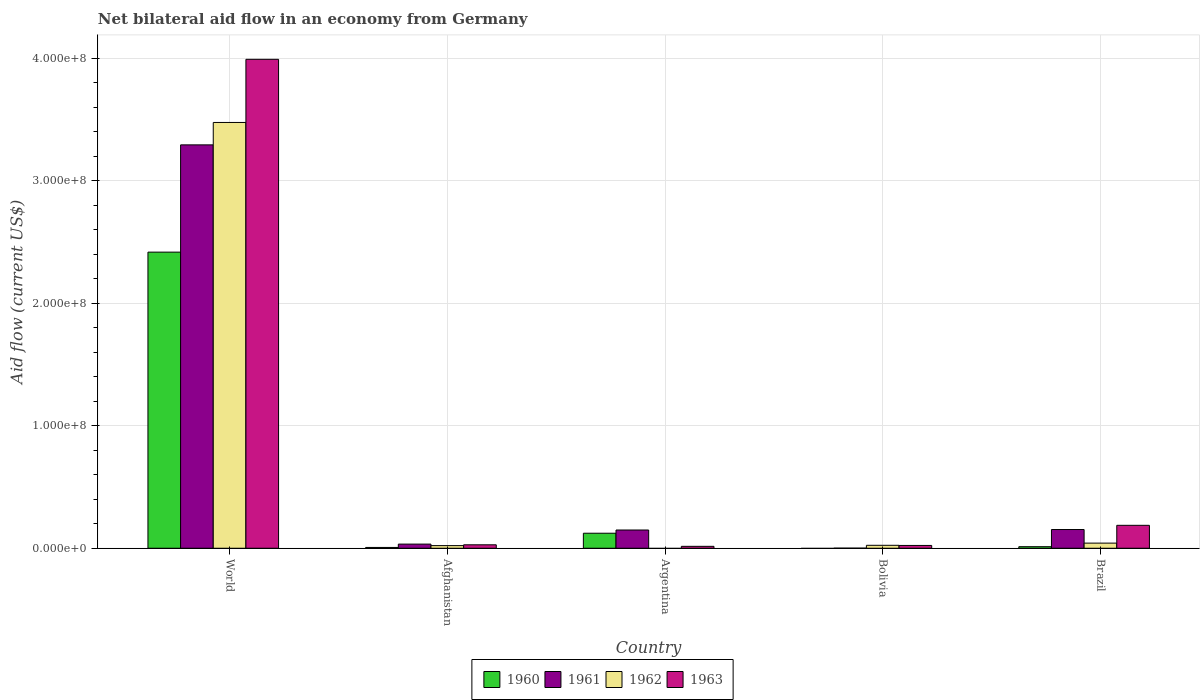How many different coloured bars are there?
Keep it short and to the point. 4. Are the number of bars per tick equal to the number of legend labels?
Make the answer very short. No. How many bars are there on the 5th tick from the left?
Your answer should be very brief. 4. What is the label of the 3rd group of bars from the left?
Offer a terse response. Argentina. What is the net bilateral aid flow in 1962 in Afghanistan?
Make the answer very short. 2.15e+06. Across all countries, what is the maximum net bilateral aid flow in 1960?
Make the answer very short. 2.42e+08. Across all countries, what is the minimum net bilateral aid flow in 1960?
Your answer should be very brief. 0. What is the total net bilateral aid flow in 1963 in the graph?
Ensure brevity in your answer.  4.24e+08. What is the difference between the net bilateral aid flow in 1962 in Afghanistan and that in Bolivia?
Your answer should be compact. -2.50e+05. What is the difference between the net bilateral aid flow in 1963 in Bolivia and the net bilateral aid flow in 1960 in Afghanistan?
Make the answer very short. 1.63e+06. What is the average net bilateral aid flow in 1961 per country?
Your answer should be compact. 7.25e+07. What is the difference between the net bilateral aid flow of/in 1961 and net bilateral aid flow of/in 1960 in World?
Ensure brevity in your answer.  8.75e+07. What is the ratio of the net bilateral aid flow in 1962 in Afghanistan to that in World?
Your response must be concise. 0.01. Is the net bilateral aid flow in 1963 in Afghanistan less than that in Bolivia?
Offer a terse response. No. What is the difference between the highest and the second highest net bilateral aid flow in 1962?
Make the answer very short. 3.45e+08. What is the difference between the highest and the lowest net bilateral aid flow in 1960?
Provide a succinct answer. 2.42e+08. Is it the case that in every country, the sum of the net bilateral aid flow in 1961 and net bilateral aid flow in 1963 is greater than the sum of net bilateral aid flow in 1960 and net bilateral aid flow in 1962?
Provide a short and direct response. No. Is it the case that in every country, the sum of the net bilateral aid flow in 1963 and net bilateral aid flow in 1961 is greater than the net bilateral aid flow in 1962?
Ensure brevity in your answer.  No. How many bars are there?
Make the answer very short. 18. Does the graph contain any zero values?
Provide a short and direct response. Yes. Where does the legend appear in the graph?
Your answer should be compact. Bottom center. How are the legend labels stacked?
Make the answer very short. Horizontal. What is the title of the graph?
Offer a terse response. Net bilateral aid flow in an economy from Germany. What is the label or title of the Y-axis?
Give a very brief answer. Aid flow (current US$). What is the Aid flow (current US$) of 1960 in World?
Provide a short and direct response. 2.42e+08. What is the Aid flow (current US$) of 1961 in World?
Ensure brevity in your answer.  3.29e+08. What is the Aid flow (current US$) in 1962 in World?
Your answer should be compact. 3.47e+08. What is the Aid flow (current US$) in 1963 in World?
Offer a very short reply. 3.99e+08. What is the Aid flow (current US$) in 1960 in Afghanistan?
Your answer should be very brief. 6.50e+05. What is the Aid flow (current US$) of 1961 in Afghanistan?
Your answer should be very brief. 3.38e+06. What is the Aid flow (current US$) of 1962 in Afghanistan?
Give a very brief answer. 2.15e+06. What is the Aid flow (current US$) of 1963 in Afghanistan?
Your answer should be compact. 2.81e+06. What is the Aid flow (current US$) of 1960 in Argentina?
Give a very brief answer. 1.23e+07. What is the Aid flow (current US$) of 1961 in Argentina?
Give a very brief answer. 1.49e+07. What is the Aid flow (current US$) in 1963 in Argentina?
Provide a succinct answer. 1.56e+06. What is the Aid flow (current US$) in 1961 in Bolivia?
Provide a short and direct response. 7.00e+04. What is the Aid flow (current US$) in 1962 in Bolivia?
Give a very brief answer. 2.40e+06. What is the Aid flow (current US$) in 1963 in Bolivia?
Provide a succinct answer. 2.28e+06. What is the Aid flow (current US$) in 1960 in Brazil?
Keep it short and to the point. 1.26e+06. What is the Aid flow (current US$) of 1961 in Brazil?
Provide a short and direct response. 1.53e+07. What is the Aid flow (current US$) in 1962 in Brazil?
Provide a succinct answer. 4.19e+06. What is the Aid flow (current US$) in 1963 in Brazil?
Keep it short and to the point. 1.87e+07. Across all countries, what is the maximum Aid flow (current US$) in 1960?
Your answer should be compact. 2.42e+08. Across all countries, what is the maximum Aid flow (current US$) of 1961?
Make the answer very short. 3.29e+08. Across all countries, what is the maximum Aid flow (current US$) in 1962?
Keep it short and to the point. 3.47e+08. Across all countries, what is the maximum Aid flow (current US$) in 1963?
Your answer should be very brief. 3.99e+08. Across all countries, what is the minimum Aid flow (current US$) of 1960?
Ensure brevity in your answer.  0. Across all countries, what is the minimum Aid flow (current US$) in 1962?
Ensure brevity in your answer.  0. Across all countries, what is the minimum Aid flow (current US$) of 1963?
Keep it short and to the point. 1.56e+06. What is the total Aid flow (current US$) in 1960 in the graph?
Give a very brief answer. 2.56e+08. What is the total Aid flow (current US$) in 1961 in the graph?
Keep it short and to the point. 3.63e+08. What is the total Aid flow (current US$) in 1962 in the graph?
Your response must be concise. 3.56e+08. What is the total Aid flow (current US$) in 1963 in the graph?
Offer a terse response. 4.24e+08. What is the difference between the Aid flow (current US$) in 1960 in World and that in Afghanistan?
Provide a succinct answer. 2.41e+08. What is the difference between the Aid flow (current US$) of 1961 in World and that in Afghanistan?
Make the answer very short. 3.26e+08. What is the difference between the Aid flow (current US$) of 1962 in World and that in Afghanistan?
Your answer should be very brief. 3.45e+08. What is the difference between the Aid flow (current US$) of 1963 in World and that in Afghanistan?
Provide a succinct answer. 3.96e+08. What is the difference between the Aid flow (current US$) of 1960 in World and that in Argentina?
Your answer should be compact. 2.29e+08. What is the difference between the Aid flow (current US$) of 1961 in World and that in Argentina?
Keep it short and to the point. 3.14e+08. What is the difference between the Aid flow (current US$) in 1963 in World and that in Argentina?
Keep it short and to the point. 3.97e+08. What is the difference between the Aid flow (current US$) of 1961 in World and that in Bolivia?
Offer a terse response. 3.29e+08. What is the difference between the Aid flow (current US$) in 1962 in World and that in Bolivia?
Your answer should be compact. 3.45e+08. What is the difference between the Aid flow (current US$) of 1963 in World and that in Bolivia?
Ensure brevity in your answer.  3.97e+08. What is the difference between the Aid flow (current US$) of 1960 in World and that in Brazil?
Ensure brevity in your answer.  2.40e+08. What is the difference between the Aid flow (current US$) in 1961 in World and that in Brazil?
Make the answer very short. 3.14e+08. What is the difference between the Aid flow (current US$) of 1962 in World and that in Brazil?
Offer a very short reply. 3.43e+08. What is the difference between the Aid flow (current US$) in 1963 in World and that in Brazil?
Ensure brevity in your answer.  3.80e+08. What is the difference between the Aid flow (current US$) of 1960 in Afghanistan and that in Argentina?
Offer a very short reply. -1.16e+07. What is the difference between the Aid flow (current US$) in 1961 in Afghanistan and that in Argentina?
Keep it short and to the point. -1.15e+07. What is the difference between the Aid flow (current US$) of 1963 in Afghanistan and that in Argentina?
Keep it short and to the point. 1.25e+06. What is the difference between the Aid flow (current US$) in 1961 in Afghanistan and that in Bolivia?
Provide a succinct answer. 3.31e+06. What is the difference between the Aid flow (current US$) in 1962 in Afghanistan and that in Bolivia?
Provide a short and direct response. -2.50e+05. What is the difference between the Aid flow (current US$) in 1963 in Afghanistan and that in Bolivia?
Your answer should be very brief. 5.30e+05. What is the difference between the Aid flow (current US$) in 1960 in Afghanistan and that in Brazil?
Your answer should be very brief. -6.10e+05. What is the difference between the Aid flow (current US$) of 1961 in Afghanistan and that in Brazil?
Your answer should be compact. -1.19e+07. What is the difference between the Aid flow (current US$) of 1962 in Afghanistan and that in Brazil?
Give a very brief answer. -2.04e+06. What is the difference between the Aid flow (current US$) in 1963 in Afghanistan and that in Brazil?
Offer a very short reply. -1.59e+07. What is the difference between the Aid flow (current US$) in 1961 in Argentina and that in Bolivia?
Your response must be concise. 1.48e+07. What is the difference between the Aid flow (current US$) of 1963 in Argentina and that in Bolivia?
Ensure brevity in your answer.  -7.20e+05. What is the difference between the Aid flow (current US$) in 1960 in Argentina and that in Brazil?
Offer a very short reply. 1.10e+07. What is the difference between the Aid flow (current US$) in 1961 in Argentina and that in Brazil?
Ensure brevity in your answer.  -3.90e+05. What is the difference between the Aid flow (current US$) of 1963 in Argentina and that in Brazil?
Provide a short and direct response. -1.71e+07. What is the difference between the Aid flow (current US$) of 1961 in Bolivia and that in Brazil?
Keep it short and to the point. -1.52e+07. What is the difference between the Aid flow (current US$) in 1962 in Bolivia and that in Brazil?
Your answer should be very brief. -1.79e+06. What is the difference between the Aid flow (current US$) of 1963 in Bolivia and that in Brazil?
Your response must be concise. -1.64e+07. What is the difference between the Aid flow (current US$) in 1960 in World and the Aid flow (current US$) in 1961 in Afghanistan?
Make the answer very short. 2.38e+08. What is the difference between the Aid flow (current US$) of 1960 in World and the Aid flow (current US$) of 1962 in Afghanistan?
Ensure brevity in your answer.  2.39e+08. What is the difference between the Aid flow (current US$) in 1960 in World and the Aid flow (current US$) in 1963 in Afghanistan?
Your answer should be very brief. 2.39e+08. What is the difference between the Aid flow (current US$) of 1961 in World and the Aid flow (current US$) of 1962 in Afghanistan?
Make the answer very short. 3.27e+08. What is the difference between the Aid flow (current US$) of 1961 in World and the Aid flow (current US$) of 1963 in Afghanistan?
Provide a short and direct response. 3.26e+08. What is the difference between the Aid flow (current US$) in 1962 in World and the Aid flow (current US$) in 1963 in Afghanistan?
Ensure brevity in your answer.  3.45e+08. What is the difference between the Aid flow (current US$) in 1960 in World and the Aid flow (current US$) in 1961 in Argentina?
Keep it short and to the point. 2.27e+08. What is the difference between the Aid flow (current US$) in 1960 in World and the Aid flow (current US$) in 1963 in Argentina?
Make the answer very short. 2.40e+08. What is the difference between the Aid flow (current US$) in 1961 in World and the Aid flow (current US$) in 1963 in Argentina?
Ensure brevity in your answer.  3.28e+08. What is the difference between the Aid flow (current US$) of 1962 in World and the Aid flow (current US$) of 1963 in Argentina?
Offer a very short reply. 3.46e+08. What is the difference between the Aid flow (current US$) of 1960 in World and the Aid flow (current US$) of 1961 in Bolivia?
Keep it short and to the point. 2.42e+08. What is the difference between the Aid flow (current US$) of 1960 in World and the Aid flow (current US$) of 1962 in Bolivia?
Give a very brief answer. 2.39e+08. What is the difference between the Aid flow (current US$) of 1960 in World and the Aid flow (current US$) of 1963 in Bolivia?
Provide a short and direct response. 2.39e+08. What is the difference between the Aid flow (current US$) in 1961 in World and the Aid flow (current US$) in 1962 in Bolivia?
Give a very brief answer. 3.27e+08. What is the difference between the Aid flow (current US$) of 1961 in World and the Aid flow (current US$) of 1963 in Bolivia?
Your answer should be compact. 3.27e+08. What is the difference between the Aid flow (current US$) of 1962 in World and the Aid flow (current US$) of 1963 in Bolivia?
Give a very brief answer. 3.45e+08. What is the difference between the Aid flow (current US$) of 1960 in World and the Aid flow (current US$) of 1961 in Brazil?
Provide a succinct answer. 2.26e+08. What is the difference between the Aid flow (current US$) in 1960 in World and the Aid flow (current US$) in 1962 in Brazil?
Your answer should be compact. 2.37e+08. What is the difference between the Aid flow (current US$) in 1960 in World and the Aid flow (current US$) in 1963 in Brazil?
Ensure brevity in your answer.  2.23e+08. What is the difference between the Aid flow (current US$) in 1961 in World and the Aid flow (current US$) in 1962 in Brazil?
Offer a terse response. 3.25e+08. What is the difference between the Aid flow (current US$) in 1961 in World and the Aid flow (current US$) in 1963 in Brazil?
Provide a succinct answer. 3.10e+08. What is the difference between the Aid flow (current US$) of 1962 in World and the Aid flow (current US$) of 1963 in Brazil?
Provide a succinct answer. 3.29e+08. What is the difference between the Aid flow (current US$) in 1960 in Afghanistan and the Aid flow (current US$) in 1961 in Argentina?
Offer a very short reply. -1.42e+07. What is the difference between the Aid flow (current US$) of 1960 in Afghanistan and the Aid flow (current US$) of 1963 in Argentina?
Provide a short and direct response. -9.10e+05. What is the difference between the Aid flow (current US$) in 1961 in Afghanistan and the Aid flow (current US$) in 1963 in Argentina?
Make the answer very short. 1.82e+06. What is the difference between the Aid flow (current US$) in 1962 in Afghanistan and the Aid flow (current US$) in 1963 in Argentina?
Provide a short and direct response. 5.90e+05. What is the difference between the Aid flow (current US$) of 1960 in Afghanistan and the Aid flow (current US$) of 1961 in Bolivia?
Provide a succinct answer. 5.80e+05. What is the difference between the Aid flow (current US$) in 1960 in Afghanistan and the Aid flow (current US$) in 1962 in Bolivia?
Give a very brief answer. -1.75e+06. What is the difference between the Aid flow (current US$) in 1960 in Afghanistan and the Aid flow (current US$) in 1963 in Bolivia?
Keep it short and to the point. -1.63e+06. What is the difference between the Aid flow (current US$) of 1961 in Afghanistan and the Aid flow (current US$) of 1962 in Bolivia?
Your answer should be very brief. 9.80e+05. What is the difference between the Aid flow (current US$) of 1961 in Afghanistan and the Aid flow (current US$) of 1963 in Bolivia?
Provide a short and direct response. 1.10e+06. What is the difference between the Aid flow (current US$) of 1960 in Afghanistan and the Aid flow (current US$) of 1961 in Brazil?
Provide a succinct answer. -1.46e+07. What is the difference between the Aid flow (current US$) of 1960 in Afghanistan and the Aid flow (current US$) of 1962 in Brazil?
Provide a short and direct response. -3.54e+06. What is the difference between the Aid flow (current US$) of 1960 in Afghanistan and the Aid flow (current US$) of 1963 in Brazil?
Provide a short and direct response. -1.80e+07. What is the difference between the Aid flow (current US$) in 1961 in Afghanistan and the Aid flow (current US$) in 1962 in Brazil?
Ensure brevity in your answer.  -8.10e+05. What is the difference between the Aid flow (current US$) in 1961 in Afghanistan and the Aid flow (current US$) in 1963 in Brazil?
Offer a very short reply. -1.53e+07. What is the difference between the Aid flow (current US$) in 1962 in Afghanistan and the Aid flow (current US$) in 1963 in Brazil?
Provide a short and direct response. -1.66e+07. What is the difference between the Aid flow (current US$) in 1960 in Argentina and the Aid flow (current US$) in 1961 in Bolivia?
Provide a short and direct response. 1.22e+07. What is the difference between the Aid flow (current US$) of 1960 in Argentina and the Aid flow (current US$) of 1962 in Bolivia?
Ensure brevity in your answer.  9.86e+06. What is the difference between the Aid flow (current US$) of 1960 in Argentina and the Aid flow (current US$) of 1963 in Bolivia?
Keep it short and to the point. 9.98e+06. What is the difference between the Aid flow (current US$) in 1961 in Argentina and the Aid flow (current US$) in 1962 in Bolivia?
Provide a succinct answer. 1.25e+07. What is the difference between the Aid flow (current US$) of 1961 in Argentina and the Aid flow (current US$) of 1963 in Bolivia?
Ensure brevity in your answer.  1.26e+07. What is the difference between the Aid flow (current US$) of 1960 in Argentina and the Aid flow (current US$) of 1961 in Brazil?
Offer a terse response. -3.01e+06. What is the difference between the Aid flow (current US$) in 1960 in Argentina and the Aid flow (current US$) in 1962 in Brazil?
Your answer should be compact. 8.07e+06. What is the difference between the Aid flow (current US$) in 1960 in Argentina and the Aid flow (current US$) in 1963 in Brazil?
Offer a very short reply. -6.44e+06. What is the difference between the Aid flow (current US$) of 1961 in Argentina and the Aid flow (current US$) of 1962 in Brazil?
Give a very brief answer. 1.07e+07. What is the difference between the Aid flow (current US$) of 1961 in Argentina and the Aid flow (current US$) of 1963 in Brazil?
Ensure brevity in your answer.  -3.82e+06. What is the difference between the Aid flow (current US$) in 1961 in Bolivia and the Aid flow (current US$) in 1962 in Brazil?
Offer a terse response. -4.12e+06. What is the difference between the Aid flow (current US$) of 1961 in Bolivia and the Aid flow (current US$) of 1963 in Brazil?
Make the answer very short. -1.86e+07. What is the difference between the Aid flow (current US$) in 1962 in Bolivia and the Aid flow (current US$) in 1963 in Brazil?
Offer a terse response. -1.63e+07. What is the average Aid flow (current US$) of 1960 per country?
Provide a succinct answer. 5.12e+07. What is the average Aid flow (current US$) in 1961 per country?
Your answer should be compact. 7.25e+07. What is the average Aid flow (current US$) of 1962 per country?
Your answer should be very brief. 7.12e+07. What is the average Aid flow (current US$) in 1963 per country?
Provide a succinct answer. 8.49e+07. What is the difference between the Aid flow (current US$) of 1960 and Aid flow (current US$) of 1961 in World?
Provide a short and direct response. -8.75e+07. What is the difference between the Aid flow (current US$) in 1960 and Aid flow (current US$) in 1962 in World?
Your answer should be very brief. -1.06e+08. What is the difference between the Aid flow (current US$) in 1960 and Aid flow (current US$) in 1963 in World?
Ensure brevity in your answer.  -1.57e+08. What is the difference between the Aid flow (current US$) of 1961 and Aid flow (current US$) of 1962 in World?
Make the answer very short. -1.83e+07. What is the difference between the Aid flow (current US$) in 1961 and Aid flow (current US$) in 1963 in World?
Provide a succinct answer. -6.98e+07. What is the difference between the Aid flow (current US$) of 1962 and Aid flow (current US$) of 1963 in World?
Make the answer very short. -5.15e+07. What is the difference between the Aid flow (current US$) in 1960 and Aid flow (current US$) in 1961 in Afghanistan?
Provide a succinct answer. -2.73e+06. What is the difference between the Aid flow (current US$) of 1960 and Aid flow (current US$) of 1962 in Afghanistan?
Make the answer very short. -1.50e+06. What is the difference between the Aid flow (current US$) in 1960 and Aid flow (current US$) in 1963 in Afghanistan?
Offer a terse response. -2.16e+06. What is the difference between the Aid flow (current US$) in 1961 and Aid flow (current US$) in 1962 in Afghanistan?
Provide a succinct answer. 1.23e+06. What is the difference between the Aid flow (current US$) of 1961 and Aid flow (current US$) of 1963 in Afghanistan?
Provide a short and direct response. 5.70e+05. What is the difference between the Aid flow (current US$) of 1962 and Aid flow (current US$) of 1963 in Afghanistan?
Offer a terse response. -6.60e+05. What is the difference between the Aid flow (current US$) in 1960 and Aid flow (current US$) in 1961 in Argentina?
Provide a succinct answer. -2.62e+06. What is the difference between the Aid flow (current US$) in 1960 and Aid flow (current US$) in 1963 in Argentina?
Offer a very short reply. 1.07e+07. What is the difference between the Aid flow (current US$) in 1961 and Aid flow (current US$) in 1963 in Argentina?
Provide a succinct answer. 1.33e+07. What is the difference between the Aid flow (current US$) in 1961 and Aid flow (current US$) in 1962 in Bolivia?
Your answer should be very brief. -2.33e+06. What is the difference between the Aid flow (current US$) of 1961 and Aid flow (current US$) of 1963 in Bolivia?
Your answer should be very brief. -2.21e+06. What is the difference between the Aid flow (current US$) of 1962 and Aid flow (current US$) of 1963 in Bolivia?
Offer a very short reply. 1.20e+05. What is the difference between the Aid flow (current US$) in 1960 and Aid flow (current US$) in 1961 in Brazil?
Provide a succinct answer. -1.40e+07. What is the difference between the Aid flow (current US$) in 1960 and Aid flow (current US$) in 1962 in Brazil?
Make the answer very short. -2.93e+06. What is the difference between the Aid flow (current US$) in 1960 and Aid flow (current US$) in 1963 in Brazil?
Your answer should be very brief. -1.74e+07. What is the difference between the Aid flow (current US$) in 1961 and Aid flow (current US$) in 1962 in Brazil?
Make the answer very short. 1.11e+07. What is the difference between the Aid flow (current US$) in 1961 and Aid flow (current US$) in 1963 in Brazil?
Give a very brief answer. -3.43e+06. What is the difference between the Aid flow (current US$) in 1962 and Aid flow (current US$) in 1963 in Brazil?
Your answer should be very brief. -1.45e+07. What is the ratio of the Aid flow (current US$) in 1960 in World to that in Afghanistan?
Keep it short and to the point. 371.71. What is the ratio of the Aid flow (current US$) of 1961 in World to that in Afghanistan?
Your answer should be compact. 97.38. What is the ratio of the Aid flow (current US$) of 1962 in World to that in Afghanistan?
Give a very brief answer. 161.59. What is the ratio of the Aid flow (current US$) in 1963 in World to that in Afghanistan?
Your answer should be very brief. 141.97. What is the ratio of the Aid flow (current US$) in 1960 in World to that in Argentina?
Your response must be concise. 19.71. What is the ratio of the Aid flow (current US$) in 1961 in World to that in Argentina?
Your response must be concise. 22.12. What is the ratio of the Aid flow (current US$) in 1963 in World to that in Argentina?
Offer a very short reply. 255.72. What is the ratio of the Aid flow (current US$) of 1961 in World to that in Bolivia?
Offer a terse response. 4701.86. What is the ratio of the Aid flow (current US$) in 1962 in World to that in Bolivia?
Offer a very short reply. 144.75. What is the ratio of the Aid flow (current US$) in 1963 in World to that in Bolivia?
Provide a succinct answer. 174.97. What is the ratio of the Aid flow (current US$) of 1960 in World to that in Brazil?
Your response must be concise. 191.75. What is the ratio of the Aid flow (current US$) of 1961 in World to that in Brazil?
Ensure brevity in your answer.  21.55. What is the ratio of the Aid flow (current US$) of 1962 in World to that in Brazil?
Offer a terse response. 82.91. What is the ratio of the Aid flow (current US$) in 1963 in World to that in Brazil?
Give a very brief answer. 21.33. What is the ratio of the Aid flow (current US$) of 1960 in Afghanistan to that in Argentina?
Keep it short and to the point. 0.05. What is the ratio of the Aid flow (current US$) of 1961 in Afghanistan to that in Argentina?
Your response must be concise. 0.23. What is the ratio of the Aid flow (current US$) in 1963 in Afghanistan to that in Argentina?
Provide a short and direct response. 1.8. What is the ratio of the Aid flow (current US$) in 1961 in Afghanistan to that in Bolivia?
Your response must be concise. 48.29. What is the ratio of the Aid flow (current US$) of 1962 in Afghanistan to that in Bolivia?
Offer a terse response. 0.9. What is the ratio of the Aid flow (current US$) of 1963 in Afghanistan to that in Bolivia?
Your answer should be compact. 1.23. What is the ratio of the Aid flow (current US$) in 1960 in Afghanistan to that in Brazil?
Ensure brevity in your answer.  0.52. What is the ratio of the Aid flow (current US$) in 1961 in Afghanistan to that in Brazil?
Provide a short and direct response. 0.22. What is the ratio of the Aid flow (current US$) in 1962 in Afghanistan to that in Brazil?
Give a very brief answer. 0.51. What is the ratio of the Aid flow (current US$) in 1963 in Afghanistan to that in Brazil?
Ensure brevity in your answer.  0.15. What is the ratio of the Aid flow (current US$) in 1961 in Argentina to that in Bolivia?
Provide a succinct answer. 212.57. What is the ratio of the Aid flow (current US$) of 1963 in Argentina to that in Bolivia?
Your answer should be very brief. 0.68. What is the ratio of the Aid flow (current US$) in 1960 in Argentina to that in Brazil?
Provide a succinct answer. 9.73. What is the ratio of the Aid flow (current US$) in 1961 in Argentina to that in Brazil?
Your answer should be very brief. 0.97. What is the ratio of the Aid flow (current US$) of 1963 in Argentina to that in Brazil?
Provide a short and direct response. 0.08. What is the ratio of the Aid flow (current US$) in 1961 in Bolivia to that in Brazil?
Ensure brevity in your answer.  0. What is the ratio of the Aid flow (current US$) in 1962 in Bolivia to that in Brazil?
Offer a terse response. 0.57. What is the ratio of the Aid flow (current US$) in 1963 in Bolivia to that in Brazil?
Keep it short and to the point. 0.12. What is the difference between the highest and the second highest Aid flow (current US$) in 1960?
Offer a very short reply. 2.29e+08. What is the difference between the highest and the second highest Aid flow (current US$) in 1961?
Your answer should be very brief. 3.14e+08. What is the difference between the highest and the second highest Aid flow (current US$) of 1962?
Make the answer very short. 3.43e+08. What is the difference between the highest and the second highest Aid flow (current US$) in 1963?
Make the answer very short. 3.80e+08. What is the difference between the highest and the lowest Aid flow (current US$) in 1960?
Keep it short and to the point. 2.42e+08. What is the difference between the highest and the lowest Aid flow (current US$) of 1961?
Give a very brief answer. 3.29e+08. What is the difference between the highest and the lowest Aid flow (current US$) of 1962?
Keep it short and to the point. 3.47e+08. What is the difference between the highest and the lowest Aid flow (current US$) of 1963?
Your response must be concise. 3.97e+08. 